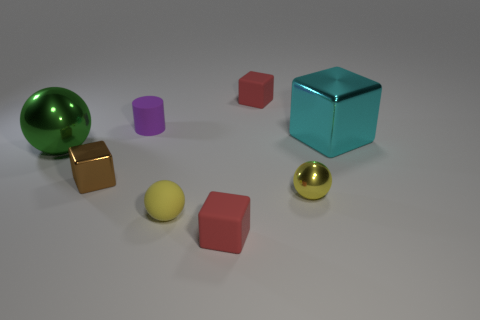Are there any other things that are the same shape as the small purple thing?
Offer a terse response. No. What number of other objects are the same material as the large green object?
Offer a terse response. 3. What number of cyan things are either big things or metallic cubes?
Make the answer very short. 1. What size is the metallic object that is the same color as the tiny matte sphere?
Give a very brief answer. Small. There is a rubber sphere; how many metal blocks are behind it?
Your response must be concise. 2. There is a yellow ball to the right of the red rubber thing in front of the matte cube behind the big green metallic ball; what is its size?
Your answer should be compact. Small. There is a yellow ball to the left of the tiny red matte block that is in front of the small brown metallic block; are there any small yellow metal objects left of it?
Give a very brief answer. No. Is the number of big cyan metallic cylinders greater than the number of purple matte cylinders?
Your response must be concise. No. There is a large shiny thing to the left of the small purple rubber cylinder; what is its color?
Offer a terse response. Green. Is the number of red cubes in front of the cyan metallic block greater than the number of cyan blocks?
Keep it short and to the point. No. 